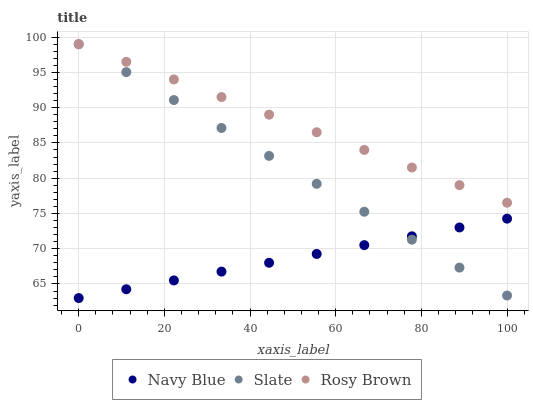Does Navy Blue have the minimum area under the curve?
Answer yes or no. Yes. Does Rosy Brown have the maximum area under the curve?
Answer yes or no. Yes. Does Slate have the minimum area under the curve?
Answer yes or no. No. Does Slate have the maximum area under the curve?
Answer yes or no. No. Is Slate the smoothest?
Answer yes or no. Yes. Is Navy Blue the roughest?
Answer yes or no. Yes. Is Rosy Brown the smoothest?
Answer yes or no. No. Is Rosy Brown the roughest?
Answer yes or no. No. Does Navy Blue have the lowest value?
Answer yes or no. Yes. Does Slate have the lowest value?
Answer yes or no. No. Does Rosy Brown have the highest value?
Answer yes or no. Yes. Is Navy Blue less than Rosy Brown?
Answer yes or no. Yes. Is Rosy Brown greater than Navy Blue?
Answer yes or no. Yes. Does Slate intersect Navy Blue?
Answer yes or no. Yes. Is Slate less than Navy Blue?
Answer yes or no. No. Is Slate greater than Navy Blue?
Answer yes or no. No. Does Navy Blue intersect Rosy Brown?
Answer yes or no. No. 